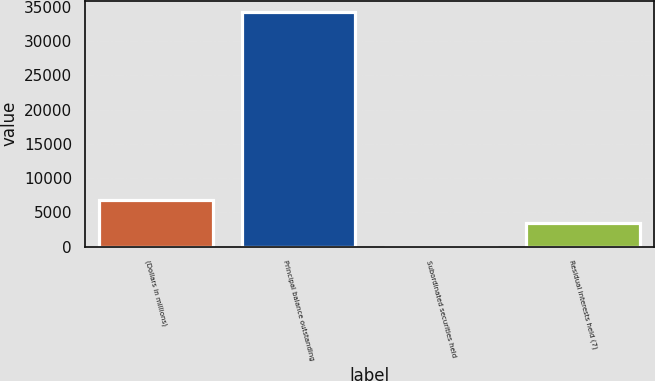Convert chart to OTSL. <chart><loc_0><loc_0><loc_500><loc_500><bar_chart><fcel>(Dollars in millions)<fcel>Principal balance outstanding<fcel>Subordinated securities held<fcel>Residual interests held (7)<nl><fcel>6836.2<fcel>34169<fcel>3<fcel>3419.6<nl></chart> 